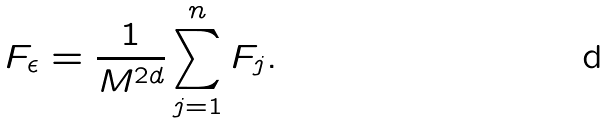Convert formula to latex. <formula><loc_0><loc_0><loc_500><loc_500>F _ { \epsilon } = \frac { 1 } { M ^ { 2 d } } \sum _ { j = 1 } ^ { n } F _ { j } .</formula> 